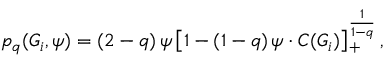<formula> <loc_0><loc_0><loc_500><loc_500>p _ { q } ( G _ { i } , \psi ) = ( 2 - q ) \, \psi \left [ 1 - ( 1 - q ) \, \psi \cdot C ( G _ { i } ) \right ] _ { + } ^ { \frac { 1 } { 1 - q } } ,</formula> 